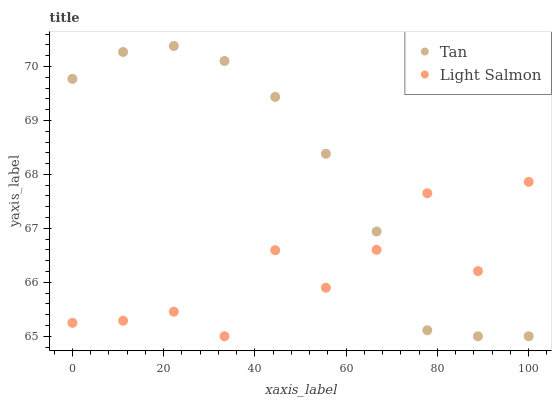Does Light Salmon have the minimum area under the curve?
Answer yes or no. Yes. Does Tan have the maximum area under the curve?
Answer yes or no. Yes. Does Light Salmon have the maximum area under the curve?
Answer yes or no. No. Is Tan the smoothest?
Answer yes or no. Yes. Is Light Salmon the roughest?
Answer yes or no. Yes. Is Light Salmon the smoothest?
Answer yes or no. No. Does Tan have the lowest value?
Answer yes or no. Yes. Does Tan have the highest value?
Answer yes or no. Yes. Does Light Salmon have the highest value?
Answer yes or no. No. Does Tan intersect Light Salmon?
Answer yes or no. Yes. Is Tan less than Light Salmon?
Answer yes or no. No. Is Tan greater than Light Salmon?
Answer yes or no. No. 